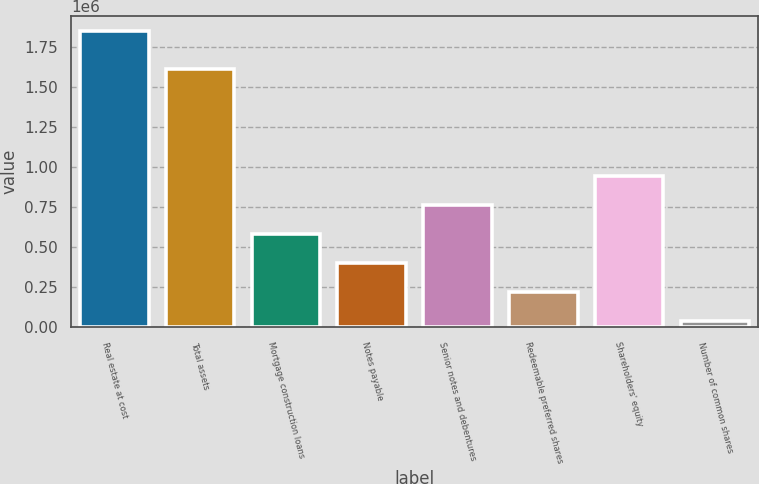<chart> <loc_0><loc_0><loc_500><loc_500><bar_chart><fcel>Real estate at cost<fcel>Total assets<fcel>Mortgage construction loans<fcel>Notes payable<fcel>Senior notes and debentures<fcel>Redeemable preferred shares<fcel>Shareholders' equity<fcel>Number of common shares<nl><fcel>1.85491e+06<fcel>1.61696e+06<fcel>584102<fcel>402558<fcel>765647<fcel>221013<fcel>947191<fcel>39469<nl></chart> 